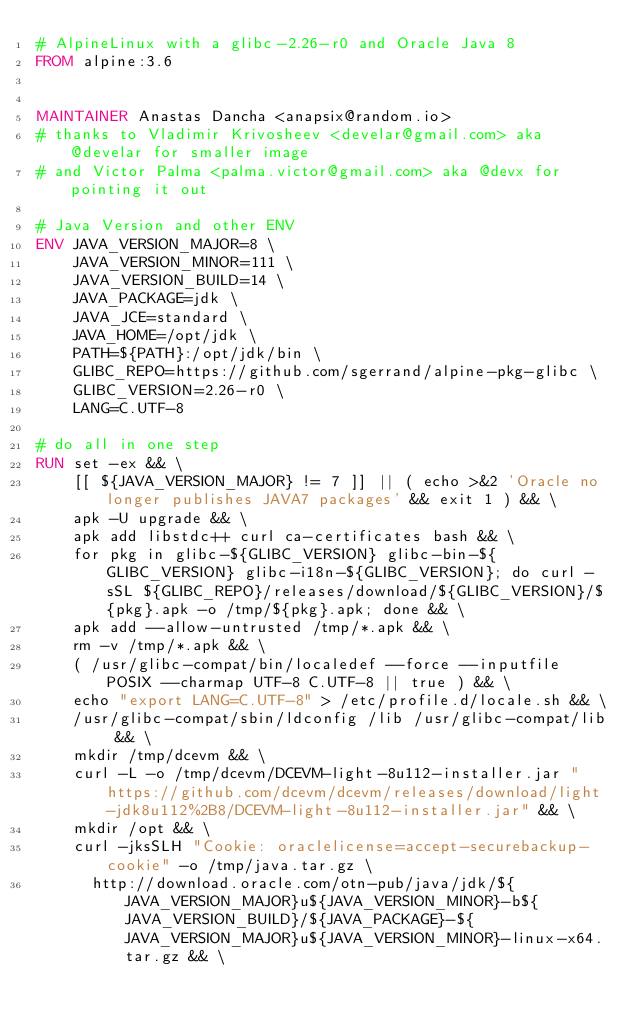Convert code to text. <code><loc_0><loc_0><loc_500><loc_500><_Dockerfile_># AlpineLinux with a glibc-2.26-r0 and Oracle Java 8
FROM alpine:3.6


MAINTAINER Anastas Dancha <anapsix@random.io>
# thanks to Vladimir Krivosheev <develar@gmail.com> aka @develar for smaller image
# and Victor Palma <palma.victor@gmail.com> aka @devx for pointing it out

# Java Version and other ENV
ENV JAVA_VERSION_MAJOR=8 \
    JAVA_VERSION_MINOR=111 \
    JAVA_VERSION_BUILD=14 \
    JAVA_PACKAGE=jdk \
    JAVA_JCE=standard \
    JAVA_HOME=/opt/jdk \
    PATH=${PATH}:/opt/jdk/bin \
    GLIBC_REPO=https://github.com/sgerrand/alpine-pkg-glibc \
    GLIBC_VERSION=2.26-r0 \
    LANG=C.UTF-8

# do all in one step
RUN set -ex && \
    [[ ${JAVA_VERSION_MAJOR} != 7 ]] || ( echo >&2 'Oracle no longer publishes JAVA7 packages' && exit 1 ) && \
    apk -U upgrade && \
    apk add libstdc++ curl ca-certificates bash && \
    for pkg in glibc-${GLIBC_VERSION} glibc-bin-${GLIBC_VERSION} glibc-i18n-${GLIBC_VERSION}; do curl -sSL ${GLIBC_REPO}/releases/download/${GLIBC_VERSION}/${pkg}.apk -o /tmp/${pkg}.apk; done && \
    apk add --allow-untrusted /tmp/*.apk && \
    rm -v /tmp/*.apk && \
    ( /usr/glibc-compat/bin/localedef --force --inputfile POSIX --charmap UTF-8 C.UTF-8 || true ) && \
    echo "export LANG=C.UTF-8" > /etc/profile.d/locale.sh && \
    /usr/glibc-compat/sbin/ldconfig /lib /usr/glibc-compat/lib && \
    mkdir /tmp/dcevm && \
    curl -L -o /tmp/dcevm/DCEVM-light-8u112-installer.jar "https://github.com/dcevm/dcevm/releases/download/light-jdk8u112%2B8/DCEVM-light-8u112-installer.jar" && \
    mkdir /opt && \
    curl -jksSLH "Cookie: oraclelicense=accept-securebackup-cookie" -o /tmp/java.tar.gz \
      http://download.oracle.com/otn-pub/java/jdk/${JAVA_VERSION_MAJOR}u${JAVA_VERSION_MINOR}-b${JAVA_VERSION_BUILD}/${JAVA_PACKAGE}-${JAVA_VERSION_MAJOR}u${JAVA_VERSION_MINOR}-linux-x64.tar.gz && \</code> 